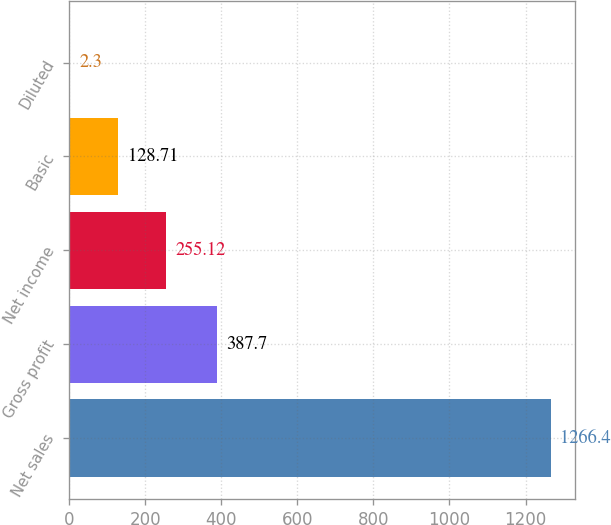Convert chart to OTSL. <chart><loc_0><loc_0><loc_500><loc_500><bar_chart><fcel>Net sales<fcel>Gross profit<fcel>Net income<fcel>Basic<fcel>Diluted<nl><fcel>1266.4<fcel>387.7<fcel>255.12<fcel>128.71<fcel>2.3<nl></chart> 